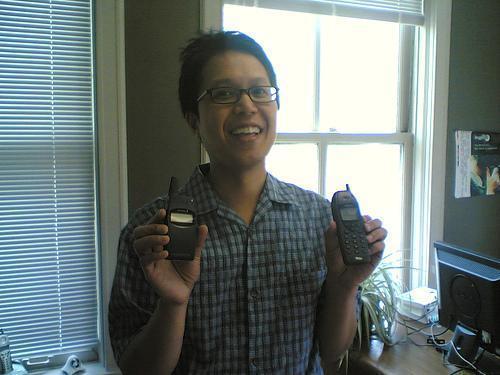How many panes of glass are in the uncovered window?
Give a very brief answer. 4. How many phones?
Give a very brief answer. 2. How many tvs can you see?
Give a very brief answer. 1. 